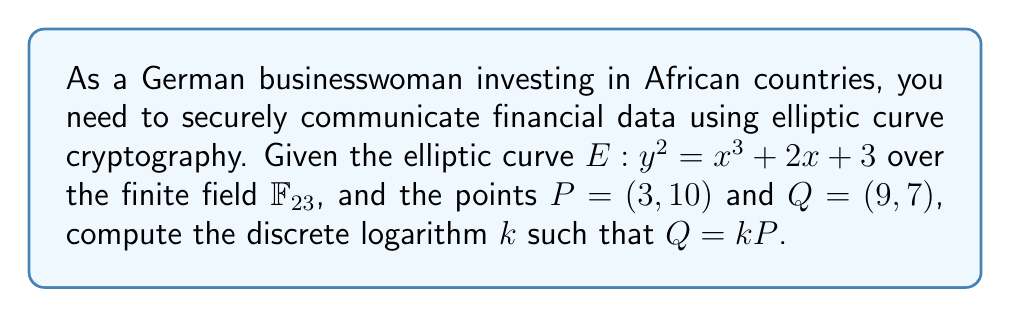Help me with this question. To solve this problem, we need to use the scalar multiplication of points on the elliptic curve until we find $k$ such that $kP = Q$. Here's the step-by-step process:

1. Start with $P = (3, 10)$ and $Q = (9, 7)$.

2. Calculate $2P$ using the point doubling formula:
   $\lambda = \frac{3x_1^2 + 2}{2y_1} \mod 23$
   $\lambda = \frac{3(3^2) + 2}{2(10)} \mod 23 = \frac{29}{20} \mod 23 = 29 \cdot 20^{-1} \mod 23 = 29 \cdot 7 \mod 23 = 19$
   $x_3 = \lambda^2 - 2x_1 \mod 23 = 19^2 - 2(3) \mod 23 = 361 - 6 \mod 23 = 10$
   $y_3 = \lambda(x_1 - x_3) - y_1 \mod 23 = 19(3 - 10) - 10 \mod 23 = -133 - 10 \mod 23 = 18$
   So, $2P = (10, 18)$

3. Calculate $3P = 2P + P$ using the point addition formula:
   $\lambda = \frac{y_2 - y_1}{x_2 - x_1} \mod 23$
   $\lambda = \frac{18 - 10}{10 - 3} \mod 23 = \frac{8}{7} \mod 23 = 8 \cdot 7^{-1} \mod 23 = 8 \cdot 10 \mod 23 = 11$
   $x_3 = \lambda^2 - x_1 - x_2 \mod 23 = 11^2 - 3 - 10 \mod 23 = 121 - 13 \mod 23 = 108 \mod 23 = 16$
   $y_3 = \lambda(x_1 - x_3) - y_1 \mod 23 = 11(3 - 16) - 10 \mod 23 = -143 - 10 \mod 23 = 16$
   So, $3P = (16, 16)$

4. Calculate $4P = 3P + P$:
   $\lambda = \frac{16 - 10}{16 - 3} \mod 23 = \frac{6}{13} \mod 23 = 6 \cdot 13^{-1} \mod 23 = 6 \cdot 16 \mod 23 = 4$
   $x_3 = 4^2 - 16 - 3 \mod 23 = 16 - 19 \mod 23 = 20$
   $y_3 = 4(16 - 20) - 16 \mod 23 = -32 \mod 23 = 14$
   So, $4P = (20, 14)$

5. Calculate $5P = 4P + P$:
   $\lambda = \frac{14 - 10}{20 - 3} \mod 23 = \frac{4}{17} \mod 23 = 4 \cdot 17^{-1} \mod 23 = 4 \cdot 19 \mod 23 = 7$
   $x_3 = 7^2 - 20 - 3 \mod 23 = 49 - 23 \mod 23 = 3$
   $y_3 = 7(20 - 3) - 14 \mod 23 = 119 - 14 \mod 23 = 13$
   So, $5P = (3, 13)$

6. Calculate $6P = 5P + P$:
   $\lambda = \frac{13 - 10}{3 - 3} \mod 23$
   This is undefined, so $6P = \mathcal{O}$ (point at infinity)

7. Calculate $7P = 6P + P = \mathcal{O} + P = P = (3, 10)$

8. Calculate $8P = 7P + P = P + P = 2P = (10, 18)$

9. Calculate $9P = 8P + P = 2P + P = 3P = (16, 16)$

We find that $Q = (9, 7)$ is not in this sequence, so we need to continue calculating multiples of $P$ until we find $Q$.

10. Calculate $10P = 9P + P = 3P + P = 4P = (20, 14)$

11. Calculate $11P = 10P + P = 4P + P = 5P = (3, 13)$

12. Calculate $12P = 11P + P = 5P + P = 6P = \mathcal{O}$

13. Calculate $13P = 12P + P = \mathcal{O} + P = P = (3, 10)$

We have completed a full cycle without finding $Q = (9, 7)$. This means that there is no integer $k$ such that $Q = kP$, and the discrete logarithm does not exist for this pair of points on the given elliptic curve.
Answer: The discrete logarithm does not exist. 